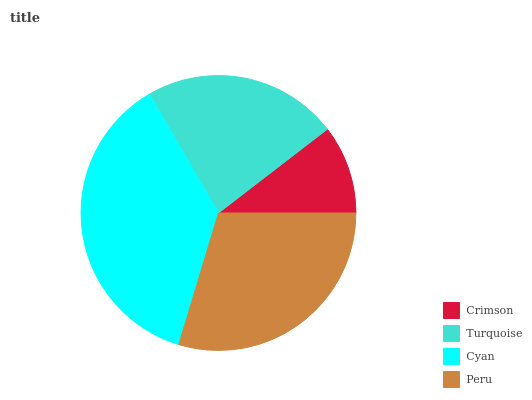Is Crimson the minimum?
Answer yes or no. Yes. Is Cyan the maximum?
Answer yes or no. Yes. Is Turquoise the minimum?
Answer yes or no. No. Is Turquoise the maximum?
Answer yes or no. No. Is Turquoise greater than Crimson?
Answer yes or no. Yes. Is Crimson less than Turquoise?
Answer yes or no. Yes. Is Crimson greater than Turquoise?
Answer yes or no. No. Is Turquoise less than Crimson?
Answer yes or no. No. Is Peru the high median?
Answer yes or no. Yes. Is Turquoise the low median?
Answer yes or no. Yes. Is Crimson the high median?
Answer yes or no. No. Is Peru the low median?
Answer yes or no. No. 